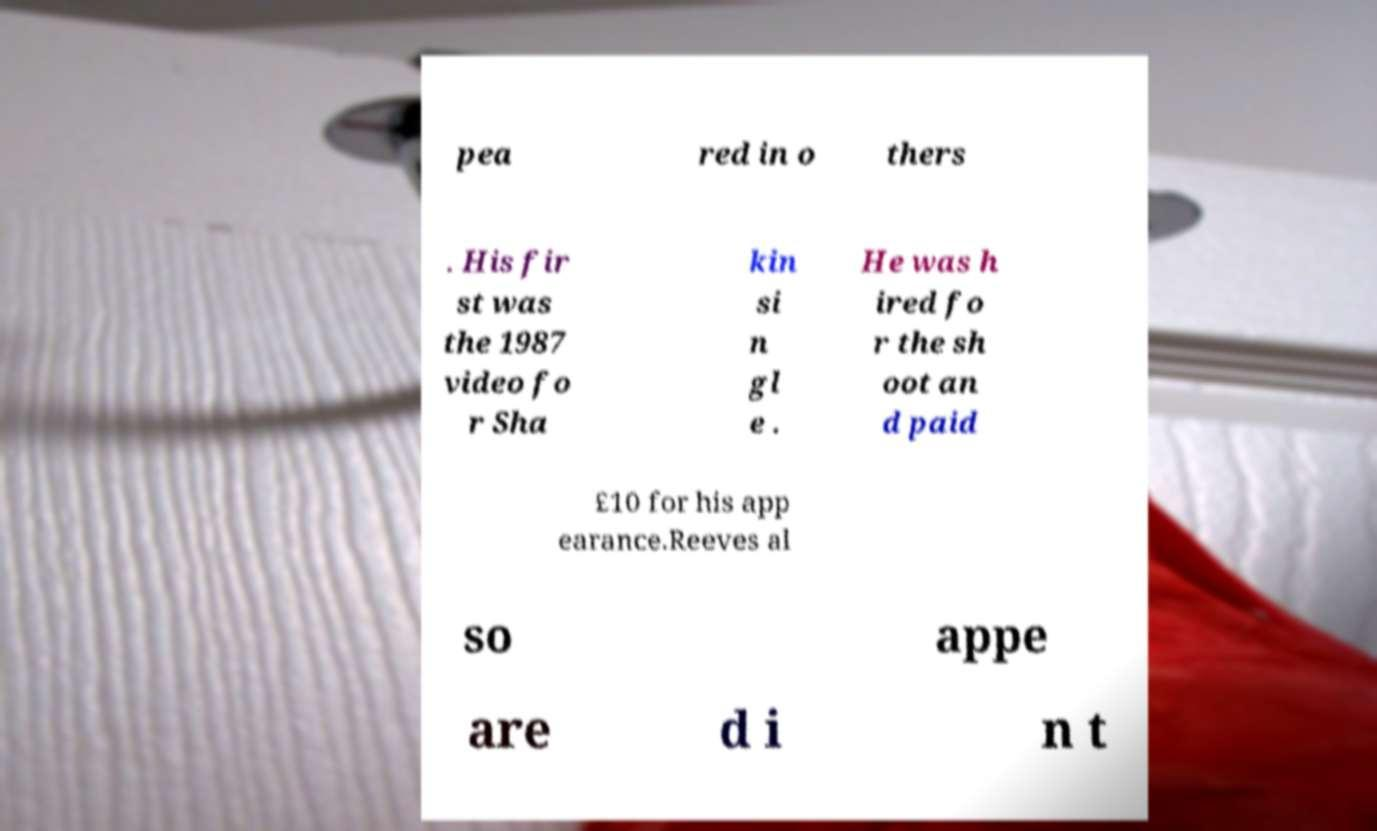Can you accurately transcribe the text from the provided image for me? pea red in o thers . His fir st was the 1987 video fo r Sha kin si n gl e . He was h ired fo r the sh oot an d paid £10 for his app earance.Reeves al so appe are d i n t 